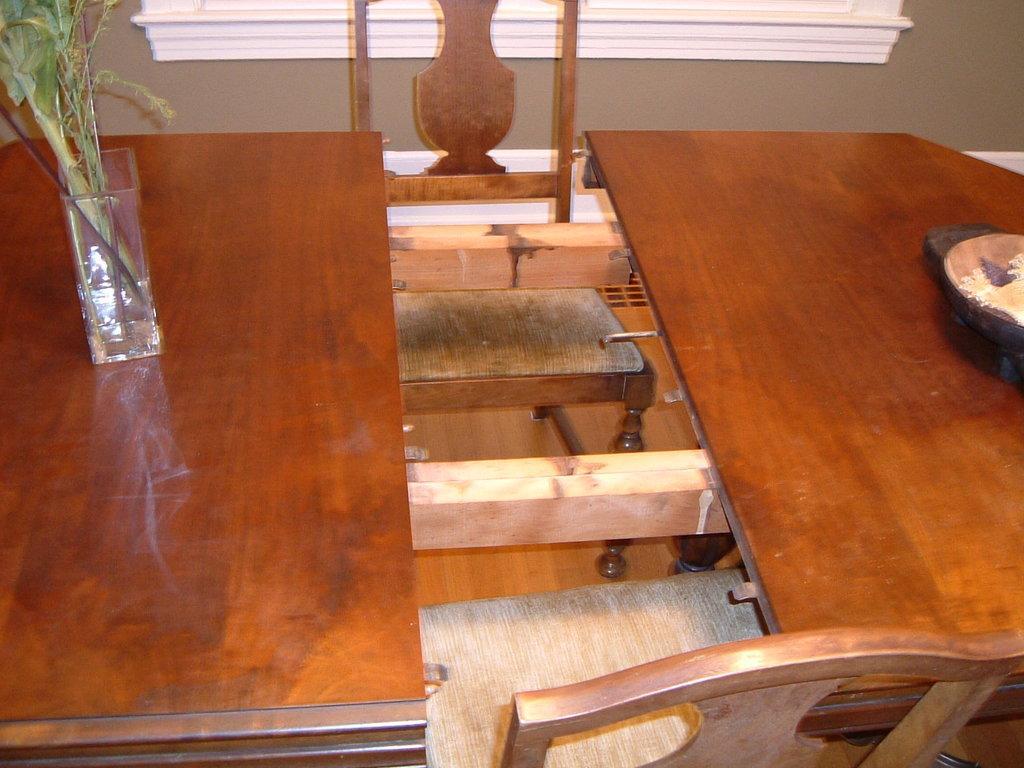Please provide a concise description of this image. In this picture we can see two tables and on this tables we have vase with plant in it, bowl with food in it and beside to them we have two chairs and in background we can see wall. 